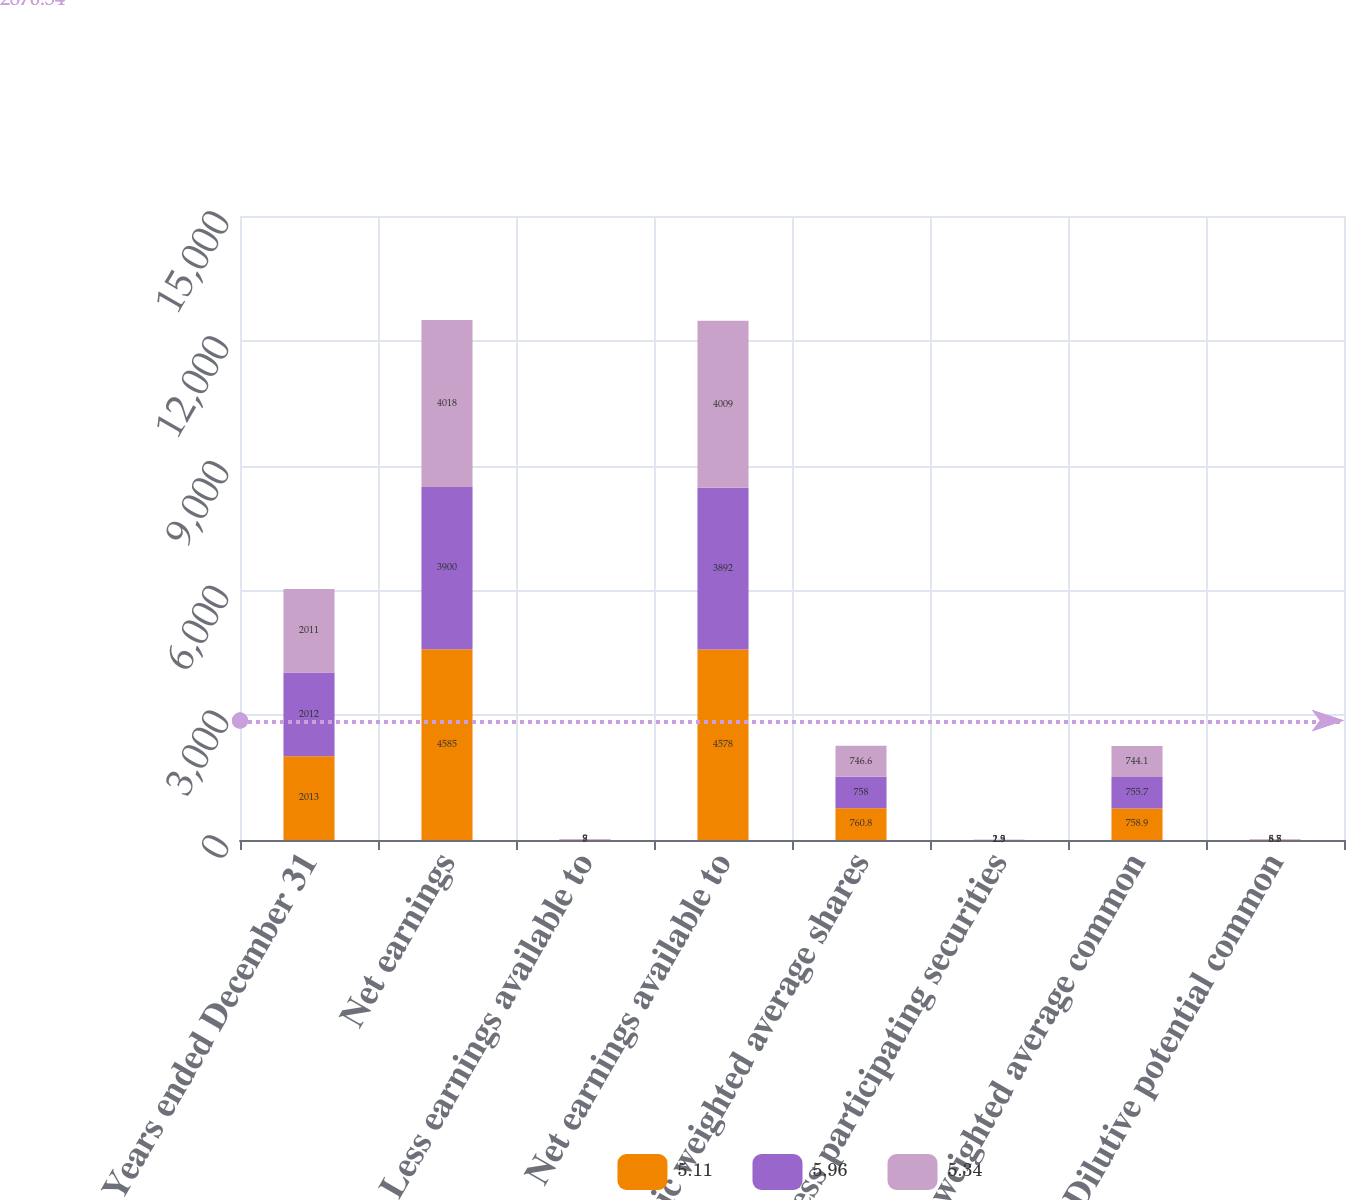Convert chart. <chart><loc_0><loc_0><loc_500><loc_500><stacked_bar_chart><ecel><fcel>Years ended December 31<fcel>Net earnings<fcel>Less earnings available to<fcel>Net earnings available to<fcel>Basic weighted average shares<fcel>Less participating securities<fcel>Basic weighted average common<fcel>Dilutive potential common<nl><fcel>5.11<fcel>2013<fcel>4585<fcel>7<fcel>4578<fcel>760.8<fcel>1.9<fcel>758.9<fcel>8.7<nl><fcel>5.96<fcel>2012<fcel>3900<fcel>8<fcel>3892<fcel>758<fcel>2.3<fcel>755.7<fcel>5.8<nl><fcel>5.34<fcel>2011<fcel>4018<fcel>9<fcel>4009<fcel>746.6<fcel>2.5<fcel>744.1<fcel>6.5<nl></chart> 